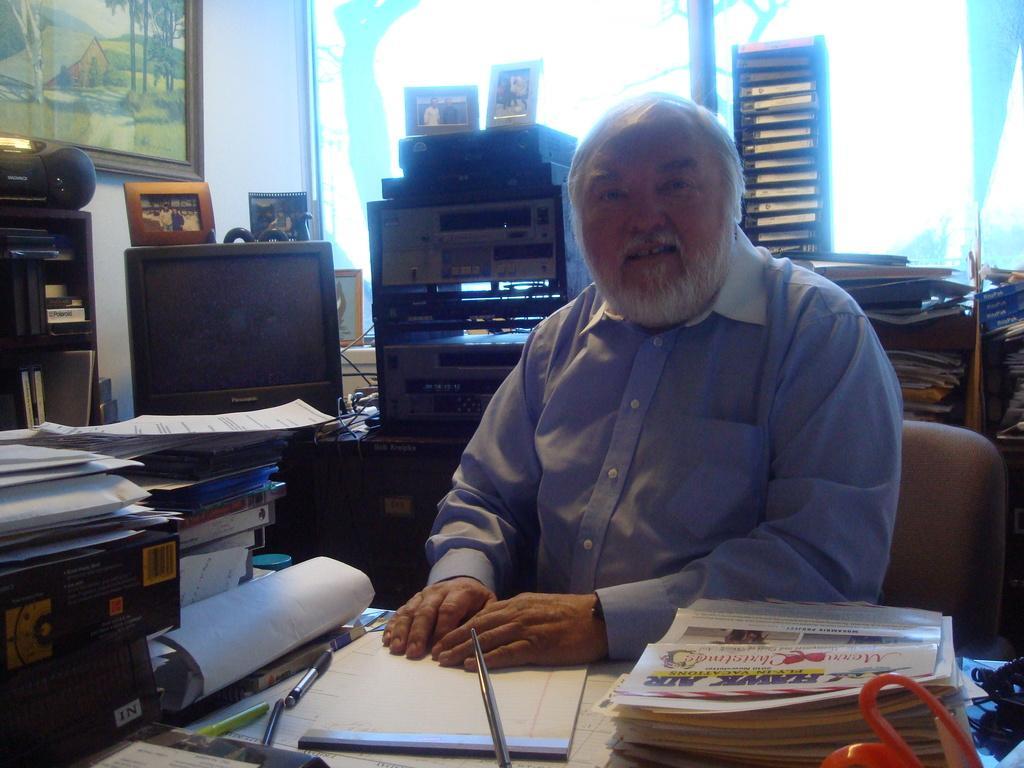Can you describe this image briefly? The image is inside the room. In the image there is a man sitting on chair in front of a table, on table we can see a news paper,book,pen,papers. On left side we can also television,photo frames,radio,wall,photo frame. In background there is a glass door which is closed. 